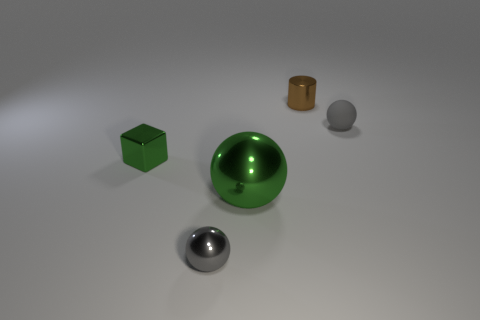Subtract 1 balls. How many balls are left? 2 Subtract all gray spheres. How many spheres are left? 1 Add 2 matte things. How many objects exist? 7 Subtract all balls. How many objects are left? 2 Subtract 1 brown cylinders. How many objects are left? 4 Subtract all balls. Subtract all brown metal objects. How many objects are left? 1 Add 5 tiny metallic cylinders. How many tiny metallic cylinders are left? 6 Add 1 green metallic blocks. How many green metallic blocks exist? 2 